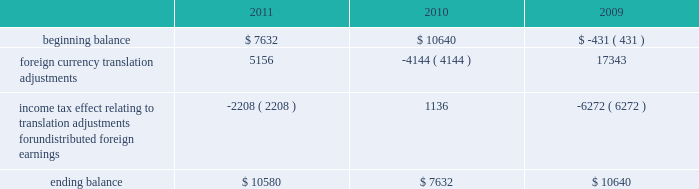The table sets forth the components of foreign currency translation adjustments for fiscal 2011 , 2010 and 2009 ( in thousands ) : beginning balance foreign currency translation adjustments income tax effect relating to translation adjustments for undistributed foreign earnings ending balance $ 7632 ( 2208 ) $ 10580 $ 10640 ( 4144 ) $ 7632 $ ( 431 ) 17343 ( 6272 ) $ 10640 stock repurchase program to facilitate our stock repurchase program , designed to return value to our stockholders and minimize dilution from stock issuances , we repurchase shares in the open market and also enter into structured repurchase agreements with third-parties .
Authorization to repurchase shares to cover on-going dilution was not subject to expiration .
However , this repurchase program was limited to covering net dilution from stock issuances and was subject to business conditions and cash flow requirements as determined by our board of directors from time to time .
During the third quarter of fiscal 2010 , our board of directors approved an amendment to our stock repurchase program authorized in april 2007 from a non-expiring share-based authority to a time-constrained dollar-based authority .
As part of this amendment , the board of directors granted authority to repurchase up to $ 1.6 billion in common stock through the end of fiscal 2012 .
This amended program did not affect the $ 250.0 million structured stock repurchase agreement entered into during march 2010 .
As of december 3 , 2010 , no prepayments remain under that agreement .
During fiscal 2011 , 2010 and 2009 , we entered into several structured repurchase agreements with large financial institutions , whereupon we provided the financial institutions with prepayments totaling $ 695.0 million , $ 850.0 million and $ 350.0 million , respectively .
Of the $ 850.0 million of prepayments during fiscal 2010 , $ 250.0 million was under the stock repurchase program prior to the program amendment and the remaining $ 600.0 million was under the amended $ 1.6 billion time-constrained dollar- based authority .
We enter into these agreements in order to take advantage of repurchasing shares at a guaranteed discount to the volume weighted average price ( 201cvwap 201d ) of our common stock over a specified period of time .
We only enter into such transactions when the discount that we receive is higher than the foregone return on our cash prepayments to the financial institutions .
There were no explicit commissions or fees on these structured repurchases .
Under the terms of the agreements , there is no requirement for the financial institutions to return any portion of the prepayment to us .
The financial institutions agree to deliver shares to us at monthly intervals during the contract term .
The parameters used to calculate the number of shares deliverable are : the total notional amount of the contract , the number of trading days in the contract , the number of trading days in the interval and the average vwap of our stock during the interval less the agreed upon discount .
During fiscal 2011 , we repurchased approximately 21.8 million shares at an average price of $ 31.81 through structured repurchase agreements entered into during fiscal 2011 .
During fiscal 2010 , we repurchased approximately 31.2 million shares at an average price of $ 29.19 through structured repurchase agreements entered into during fiscal 2009 and fiscal 2010 .
During fiscal 2009 , we repurchased approximately 15.2 million shares at an average price per share of $ 27.89 through structured repurchase agreements entered into during fiscal 2008 and fiscal 2009 .
For fiscal 2011 , 2010 and 2009 , the prepayments were classified as treasury stock on our consolidated balance sheets at the payment date , though only shares physically delivered to us by december 2 , 2011 , december 3 , 2010 and november 27 , 2009 were excluded from the computation of earnings per share .
As of december 2 , 2011 and december 3 , 2010 , no prepayments remained under these agreements .
As of november 27 , 2009 , approximately $ 59.9 million of prepayments remained under these agreements .
Subsequent to december 2 , 2011 , as part of our $ 1.6 billion stock repurchase program , we entered into a structured stock repurchase agreement with a large financial institution whereupon we provided them with a prepayment of $ 80.0 million .
This amount will be classified as treasury stock on our consolidated balance sheets .
Upon completion of the $ 80.0 million stock table of contents adobe systems incorporated notes to consolidated financial statements ( continued ) jarcamo typewritten text .
The following table sets forth the components of foreign currency translation adjustments for fiscal 2011 , 2010 and 2009 ( in thousands ) : beginning balance foreign currency translation adjustments income tax effect relating to translation adjustments for undistributed foreign earnings ending balance $ 7632 ( 2208 ) $ 10580 $ 10640 ( 4144 ) $ 7632 $ ( 431 ) 17343 ( 6272 ) $ 10640 stock repurchase program to facilitate our stock repurchase program , designed to return value to our stockholders and minimize dilution from stock issuances , we repurchase shares in the open market and also enter into structured repurchase agreements with third-parties .
Authorization to repurchase shares to cover on-going dilution was not subject to expiration .
However , this repurchase program was limited to covering net dilution from stock issuances and was subject to business conditions and cash flow requirements as determined by our board of directors from time to time .
During the third quarter of fiscal 2010 , our board of directors approved an amendment to our stock repurchase program authorized in april 2007 from a non-expiring share-based authority to a time-constrained dollar-based authority .
As part of this amendment , the board of directors granted authority to repurchase up to $ 1.6 billion in common stock through the end of fiscal 2012 .
This amended program did not affect the $ 250.0 million structured stock repurchase agreement entered into during march 2010 .
As of december 3 , 2010 , no prepayments remain under that agreement .
During fiscal 2011 , 2010 and 2009 , we entered into several structured repurchase agreements with large financial institutions , whereupon we provided the financial institutions with prepayments totaling $ 695.0 million , $ 850.0 million and $ 350.0 million , respectively .
Of the $ 850.0 million of prepayments during fiscal 2010 , $ 250.0 million was under the stock repurchase program prior to the program amendment and the remaining $ 600.0 million was under the amended $ 1.6 billion time-constrained dollar- based authority .
We enter into these agreements in order to take advantage of repurchasing shares at a guaranteed discount to the volume weighted average price ( 201cvwap 201d ) of our common stock over a specified period of time .
We only enter into such transactions when the discount that we receive is higher than the foregone return on our cash prepayments to the financial institutions .
There were no explicit commissions or fees on these structured repurchases .
Under the terms of the agreements , there is no requirement for the financial institutions to return any portion of the prepayment to us .
The financial institutions agree to deliver shares to us at monthly intervals during the contract term .
The parameters used to calculate the number of shares deliverable are : the total notional amount of the contract , the number of trading days in the contract , the number of trading days in the interval and the average vwap of our stock during the interval less the agreed upon discount .
During fiscal 2011 , we repurchased approximately 21.8 million shares at an average price of $ 31.81 through structured repurchase agreements entered into during fiscal 2011 .
During fiscal 2010 , we repurchased approximately 31.2 million shares at an average price of $ 29.19 through structured repurchase agreements entered into during fiscal 2009 and fiscal 2010 .
During fiscal 2009 , we repurchased approximately 15.2 million shares at an average price per share of $ 27.89 through structured repurchase agreements entered into during fiscal 2008 and fiscal 2009 .
For fiscal 2011 , 2010 and 2009 , the prepayments were classified as treasury stock on our consolidated balance sheets at the payment date , though only shares physically delivered to us by december 2 , 2011 , december 3 , 2010 and november 27 , 2009 were excluded from the computation of earnings per share .
As of december 2 , 2011 and december 3 , 2010 , no prepayments remained under these agreements .
As of november 27 , 2009 , approximately $ 59.9 million of prepayments remained under these agreements .
Subsequent to december 2 , 2011 , as part of our $ 1.6 billion stock repurchase program , we entered into a structured stock repurchase agreement with a large financial institution whereupon we provided them with a prepayment of $ 80.0 million .
This amount will be classified as treasury stock on our consolidated balance sheets .
Upon completion of the $ 80.0 million stock table of contents adobe systems incorporated notes to consolidated financial statements ( continued ) jarcamo typewritten text .
What is the growth rate in the average price of repurchased shares from 2009 to 2010? 
Computations: ((29.19 - 27.89) / 27.89)
Answer: 0.04661. 